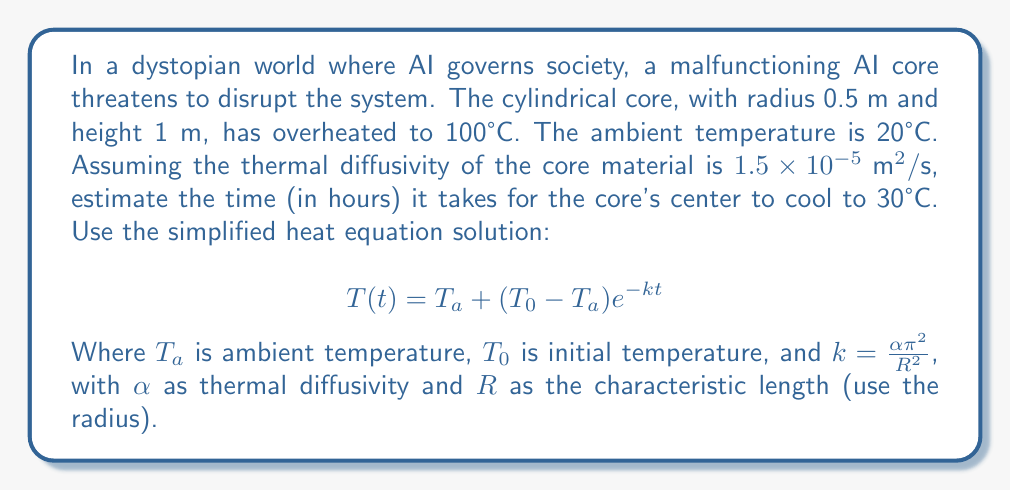Teach me how to tackle this problem. Let's approach this problem step-by-step:

1) First, we need to identify our variables:
   $T_a = 20°C$ (ambient temperature)
   $T_0 = 100°C$ (initial temperature)
   $T(t) = 30°C$ (final temperature we're solving for)
   $\alpha = 1.5 \times 10^{-5} \text{ m}^2/\text{s}$ (thermal diffusivity)
   $R = 0.5 \text{ m}$ (radius of the cylinder)

2) We need to calculate $k$:
   $k = \frac{\alpha \pi^2}{R^2} = \frac{(1.5 \times 10^{-5}) \pi^2}{(0.5)^2} = 1.8849 \times 10^{-4} \text{ s}^{-1}$

3) Now we can use the equation and solve for $t$:
   $$ 30 = 20 + (100 - 20) e^{-kt} $$

4) Simplify:
   $$ 10 = 80 e^{-kt} $$

5) Take natural log of both sides:
   $$ \ln(\frac{10}{80}) = -kt $$

6) Solve for $t$:
   $$ t = -\frac{\ln(\frac{1}{8})}{k} = -\frac{\ln(0.125)}{1.8849 \times 10^{-4}} = 11,060 \text{ seconds} $$

7) Convert to hours:
   $$ 11,060 \text{ seconds} = 3.0722 \text{ hours} $$
Answer: 3.07 hours 